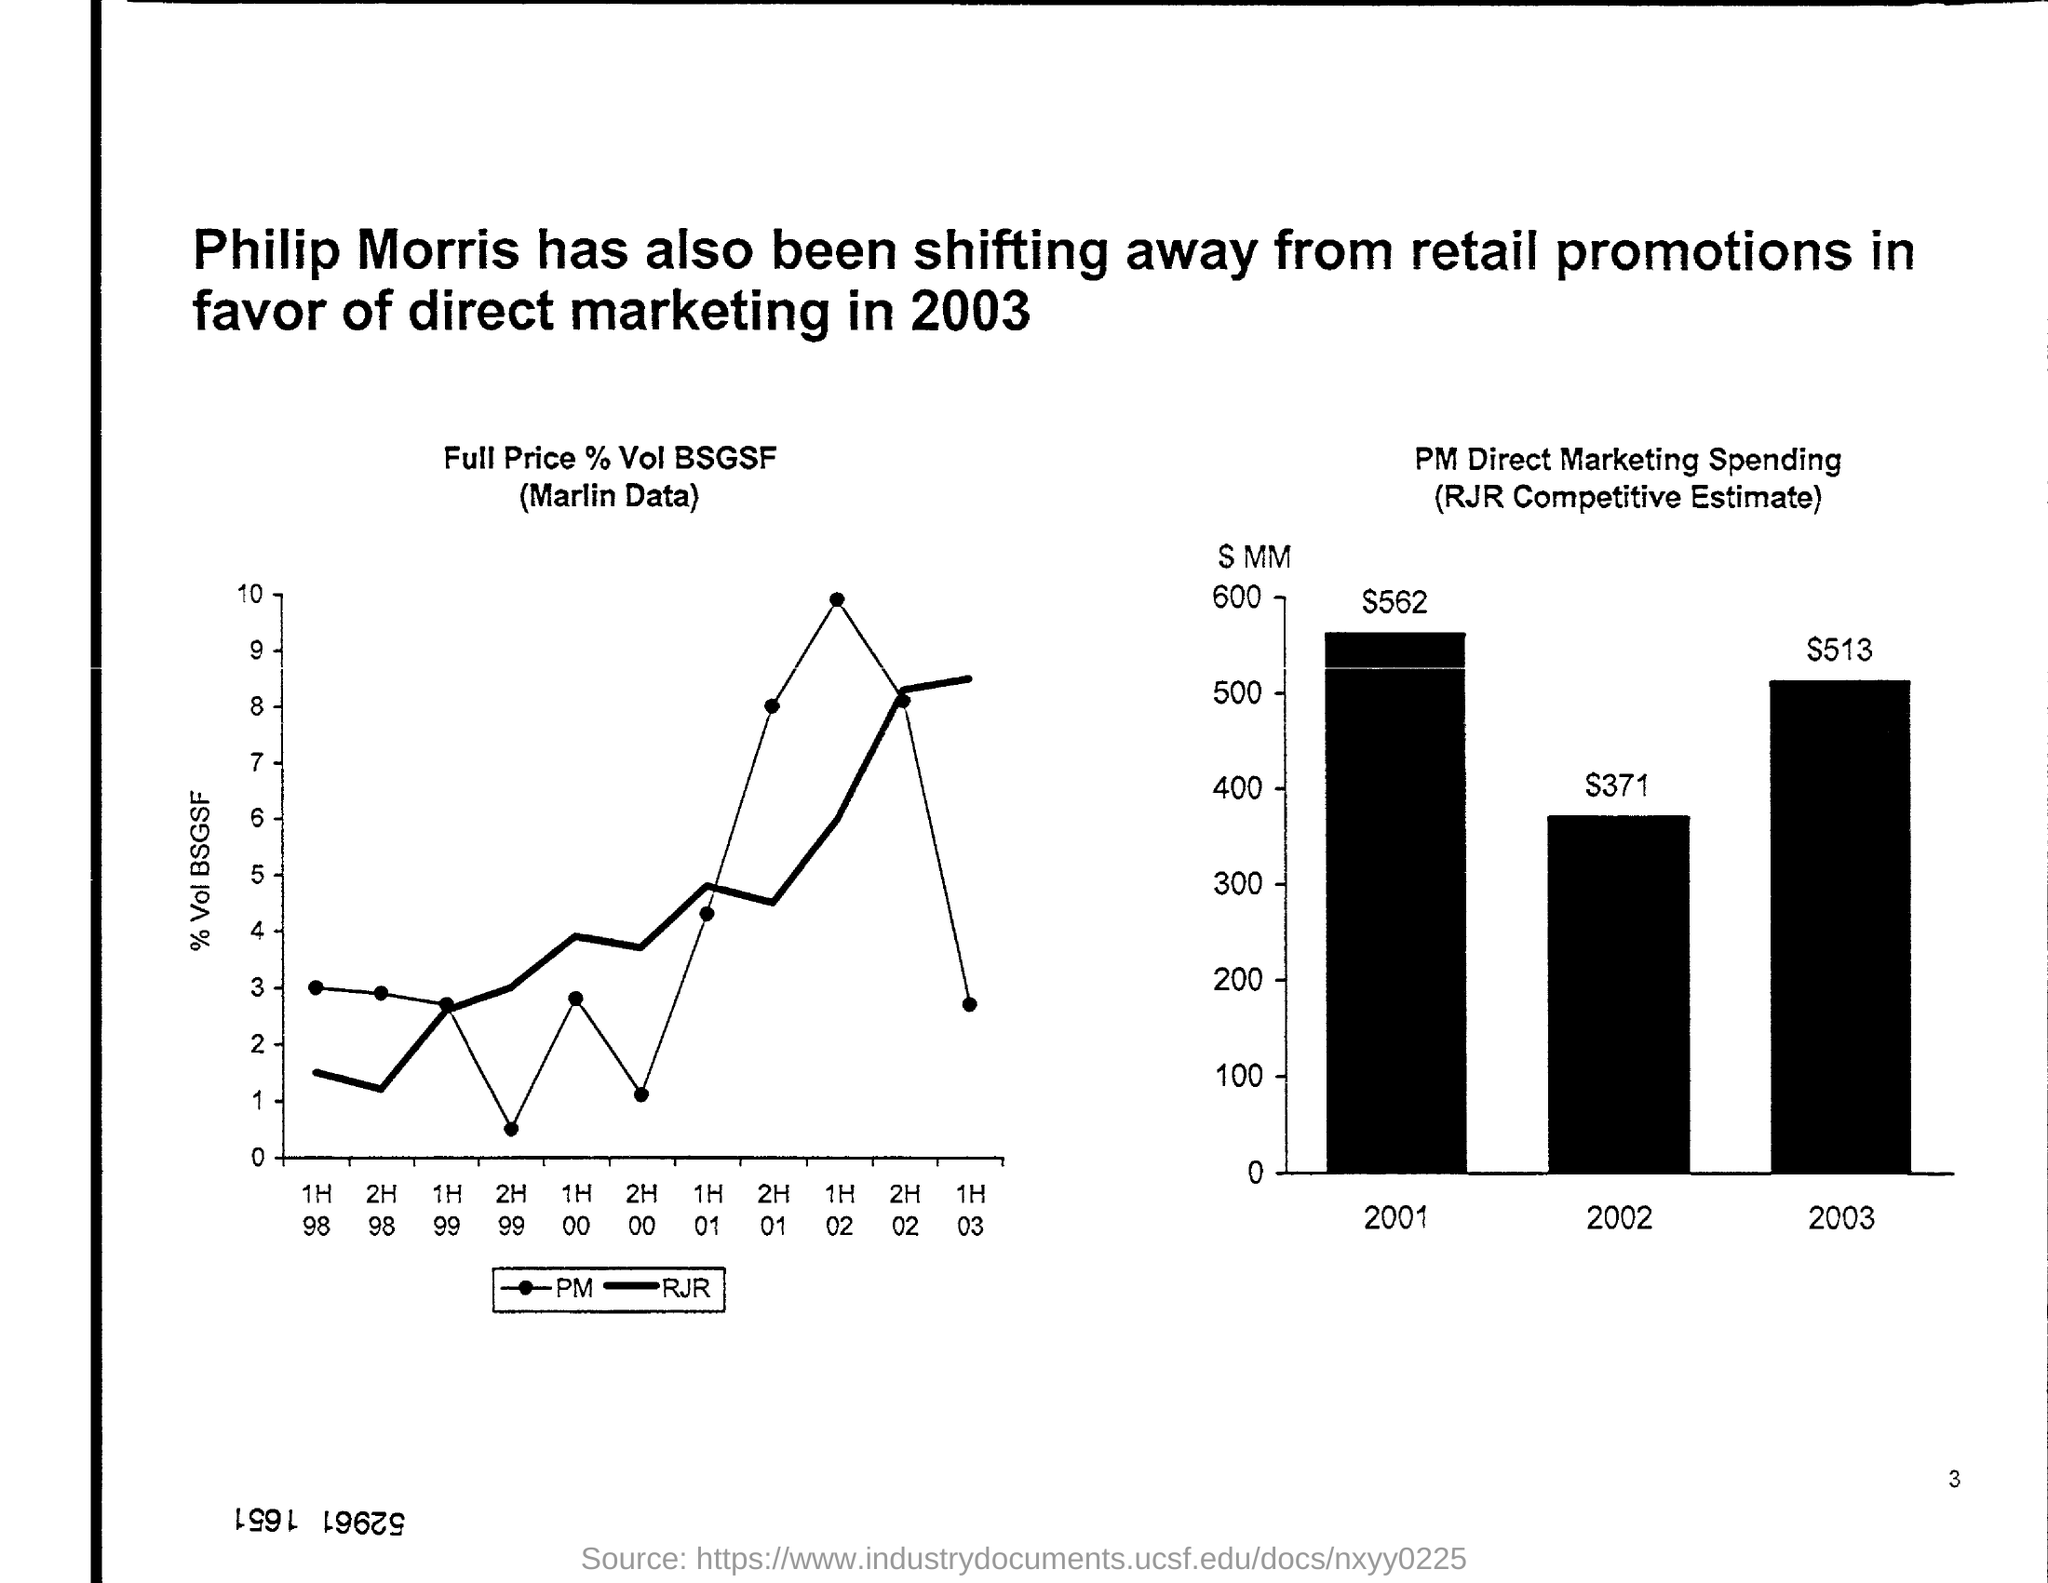Specify some key components in this picture. The graph shows the percentage of full price tickets sold for an event, as well as the volume of bottle service sales and the amount of boosted group sales. In 2003, Philip Morris made the shift away from retail promotions and towards direct marketing. The title of the bar chart is "PM Direct Marketing Spending (RJR Competitive Estimate)," which provides a comprehensive overview of the spending in the PM Direct Marketing category for the RJR competitive estimate. The RJR Competitive Estimate in the year 2002 was $371. 